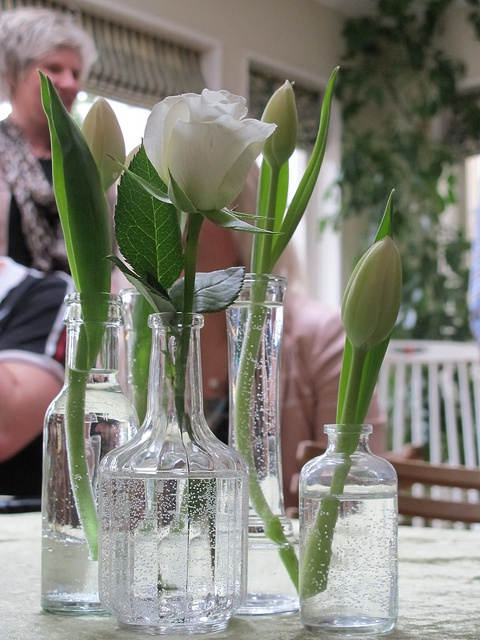Describe the objects in this image and their specific colors. I can see vase in gray, darkgray, and lightgray tones, vase in gray, darkgray, lightgray, and darkgreen tones, vase in gray, lightgray, darkgray, and darkgreen tones, people in gray, brown, and maroon tones, and people in gray, darkgray, and black tones in this image. 